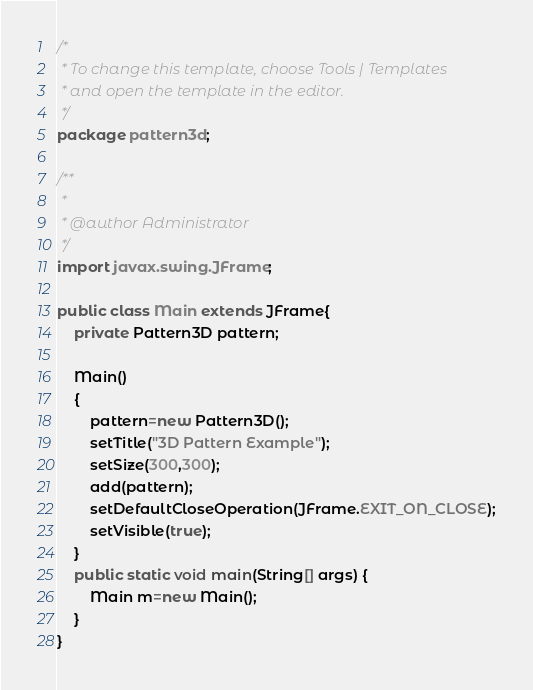Convert code to text. <code><loc_0><loc_0><loc_500><loc_500><_Java_>/*
 * To change this template, choose Tools | Templates
 * and open the template in the editor.
 */
package pattern3d;

/**
 *
 * @author Administrator
 */
import javax.swing.JFrame;

public class Main extends JFrame{
    private Pattern3D pattern;
    
    Main()
    {
        pattern=new Pattern3D();
        setTitle("3D Pattern Example");
        setSize(300,300);
        add(pattern);
        setDefaultCloseOperation(JFrame.EXIT_ON_CLOSE);
        setVisible(true);
    }
    public static void main(String[] args) {
        Main m=new Main();
    }
}
</code> 